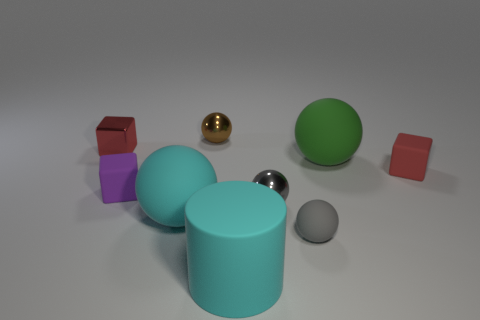There is a sphere that is behind the small red cube behind the tiny matte thing on the right side of the large green matte thing; what is its size?
Offer a very short reply. Small. There is a red shiny object; is its shape the same as the large cyan thing that is in front of the large cyan ball?
Provide a short and direct response. No. What number of other objects are there of the same size as the purple thing?
Keep it short and to the point. 5. How big is the rubber block right of the brown object?
Offer a terse response. Small. How many small purple blocks have the same material as the brown ball?
Provide a short and direct response. 0. Is the shape of the big matte thing on the right side of the rubber cylinder the same as  the small brown shiny thing?
Your answer should be compact. Yes. What shape is the object on the left side of the purple matte cube?
Your answer should be very brief. Cube. What is the size of the matte ball that is the same color as the large rubber cylinder?
Ensure brevity in your answer.  Large. What is the big green ball made of?
Offer a very short reply. Rubber. There is a rubber cube that is the same size as the red rubber thing; what color is it?
Offer a terse response. Purple. 